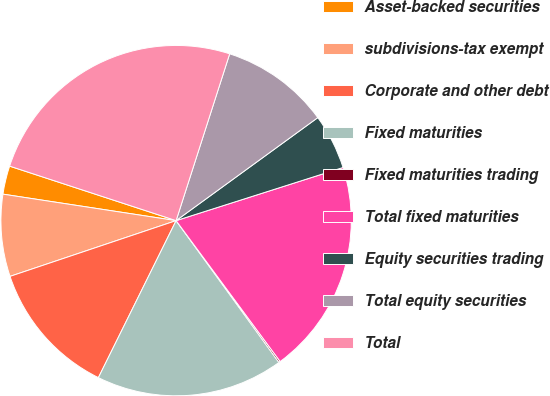<chart> <loc_0><loc_0><loc_500><loc_500><pie_chart><fcel>Asset-backed securities<fcel>subdivisions-tax exempt<fcel>Corporate and other debt<fcel>Fixed maturities<fcel>Fixed maturities trading<fcel>Total fixed maturities<fcel>Equity securities trading<fcel>Total equity securities<fcel>Total<nl><fcel>2.62%<fcel>7.57%<fcel>12.53%<fcel>17.3%<fcel>0.14%<fcel>19.78%<fcel>5.1%<fcel>10.05%<fcel>24.91%<nl></chart> 